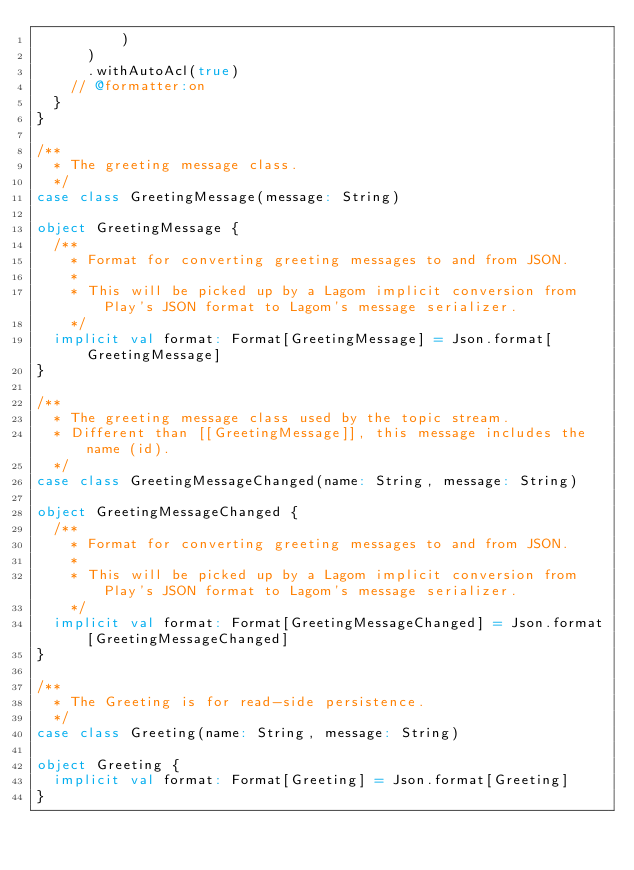Convert code to text. <code><loc_0><loc_0><loc_500><loc_500><_Scala_>          )
      )
      .withAutoAcl(true)
    // @formatter:on
  }
}

/**
  * The greeting message class.
  */
case class GreetingMessage(message: String)

object GreetingMessage {
  /**
    * Format for converting greeting messages to and from JSON.
    *
    * This will be picked up by a Lagom implicit conversion from Play's JSON format to Lagom's message serializer.
    */
  implicit val format: Format[GreetingMessage] = Json.format[GreetingMessage]
}

/**
  * The greeting message class used by the topic stream.
  * Different than [[GreetingMessage]], this message includes the name (id).
  */
case class GreetingMessageChanged(name: String, message: String)

object GreetingMessageChanged {
  /**
    * Format for converting greeting messages to and from JSON.
    *
    * This will be picked up by a Lagom implicit conversion from Play's JSON format to Lagom's message serializer.
    */
  implicit val format: Format[GreetingMessageChanged] = Json.format[GreetingMessageChanged]
}

/**
  * The Greeting is for read-side persistence.
  */
case class Greeting(name: String, message: String)

object Greeting {
  implicit val format: Format[Greeting] = Json.format[Greeting]
}
</code> 